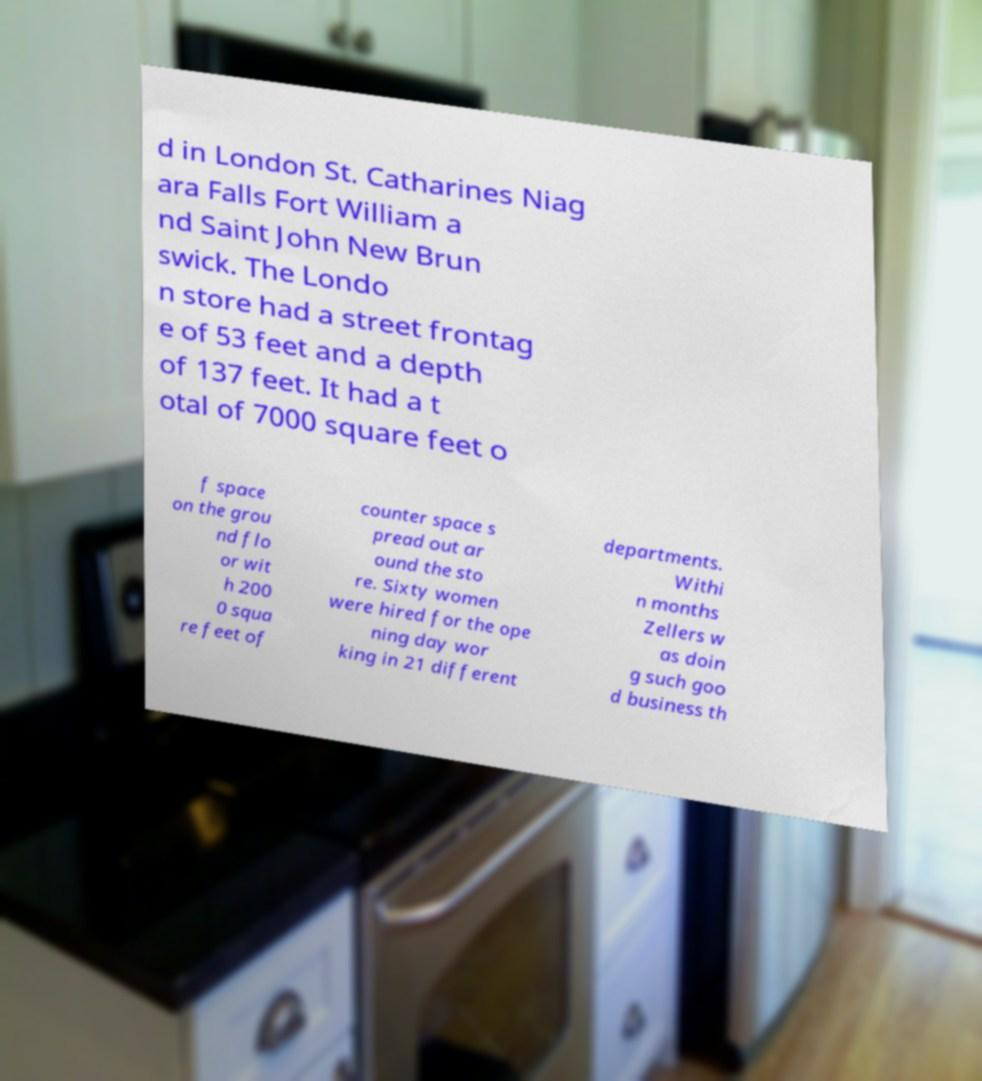Please read and relay the text visible in this image. What does it say? d in London St. Catharines Niag ara Falls Fort William a nd Saint John New Brun swick. The Londo n store had a street frontag e of 53 feet and a depth of 137 feet. It had a t otal of 7000 square feet o f space on the grou nd flo or wit h 200 0 squa re feet of counter space s pread out ar ound the sto re. Sixty women were hired for the ope ning day wor king in 21 different departments. Withi n months Zellers w as doin g such goo d business th 